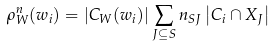Convert formula to latex. <formula><loc_0><loc_0><loc_500><loc_500>\rho _ { W } ^ { n } ( w _ { i } ) = | C _ { W } ( w _ { i } ) | \sum _ { J \subseteq S } n _ { S J } \left | C _ { i } \cap X _ { J } \right |</formula> 